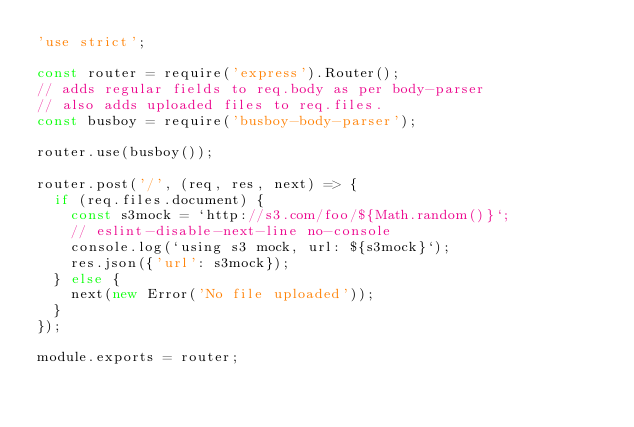Convert code to text. <code><loc_0><loc_0><loc_500><loc_500><_JavaScript_>'use strict';

const router = require('express').Router();
// adds regular fields to req.body as per body-parser
// also adds uploaded files to req.files.
const busboy = require('busboy-body-parser');

router.use(busboy());

router.post('/', (req, res, next) => {
  if (req.files.document) {
    const s3mock = `http://s3.com/foo/${Math.random()}`;
    // eslint-disable-next-line no-console
    console.log(`using s3 mock, url: ${s3mock}`);
    res.json({'url': s3mock});
  } else {
    next(new Error('No file uploaded'));
  }
});

module.exports = router;
</code> 